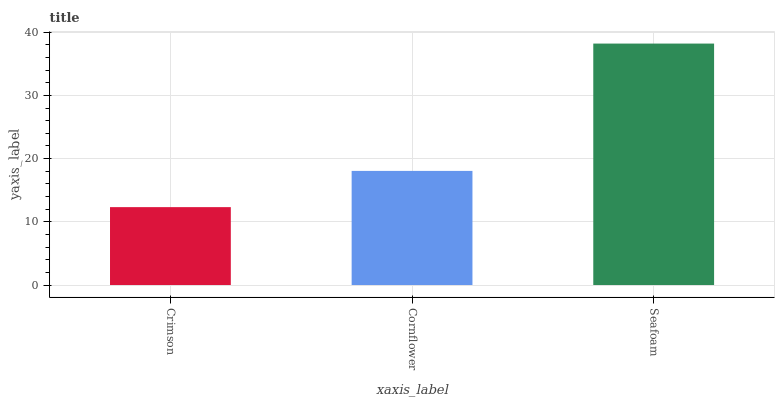Is Crimson the minimum?
Answer yes or no. Yes. Is Seafoam the maximum?
Answer yes or no. Yes. Is Cornflower the minimum?
Answer yes or no. No. Is Cornflower the maximum?
Answer yes or no. No. Is Cornflower greater than Crimson?
Answer yes or no. Yes. Is Crimson less than Cornflower?
Answer yes or no. Yes. Is Crimson greater than Cornflower?
Answer yes or no. No. Is Cornflower less than Crimson?
Answer yes or no. No. Is Cornflower the high median?
Answer yes or no. Yes. Is Cornflower the low median?
Answer yes or no. Yes. Is Seafoam the high median?
Answer yes or no. No. Is Seafoam the low median?
Answer yes or no. No. 